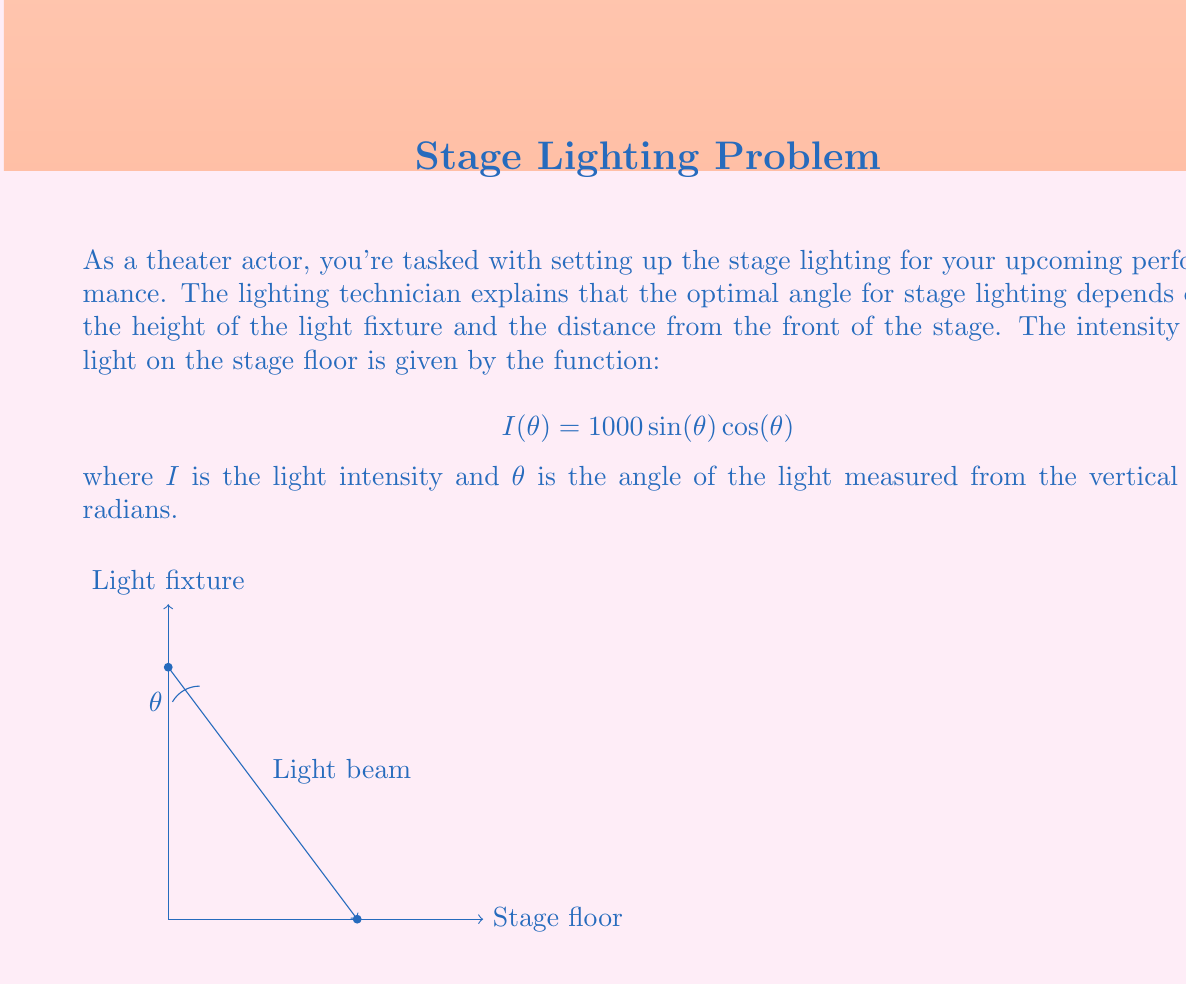Could you help me with this problem? Let's approach this step-by-step:

1) We need to find the maximum of the function $I(θ) = 1000 \sin(θ) \cos(θ)$. To do this, we'll use calculus to find where the derivative of $I(θ)$ equals zero.

2) First, let's simplify our function using the trigonometric identity $\sin(2θ) = 2\sin(θ)\cos(θ)$:

   $$I(θ) = 1000 \sin(θ) \cos(θ) = 500 \sin(2θ)$$

3) Now, let's find the derivative of $I(θ)$:

   $$I'(θ) = 500 \cdot 2 \cos(2θ) = 1000 \cos(2θ)$$

4) Set the derivative equal to zero and solve for $θ$:

   $$1000 \cos(2θ) = 0$$
   $$\cos(2θ) = 0$$

5) The cosine function equals zero when its argument is $\frac{\pi}{2}$ or $\frac{3\pi}{2}$ radians. So:

   $$2θ = \frac{\pi}{2}$$ or $$2θ = \frac{3\pi}{2}$$

6) Solving for $θ$:

   $$θ = \frac{\pi}{4}$$ or $$θ = \frac{3\pi}{4}$$

7) To determine which of these gives the maximum (rather than minimum) intensity, we can check the second derivative or simply evaluate $I(θ)$ at both points. The maximum occurs at $θ = \frac{\pi}{4}$.

8) Convert $\frac{\pi}{4}$ radians to degrees:

   $$\frac{\pi}{4} \cdot \frac{180°}{\pi} = 45°$$

Therefore, the optimal angle for maximum light intensity is 45°.
Answer: 45° 